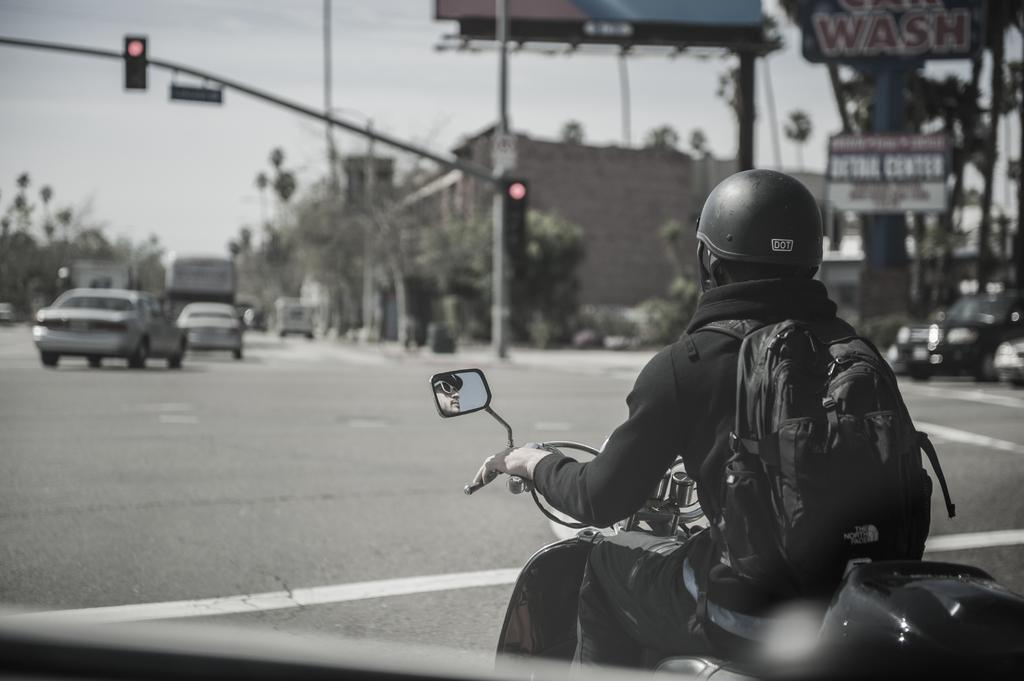What is the person in the image doing? The person is sitting and riding a bike. What is the person wearing while riding the bike? The person is wearing a bag and a helmet. What can be seen on the road in the image? There are vehicles on the road. What is visible in the distance in the image? There is a traffic signal with a pole, a building, boards, trees, and the sky. What type of bead is being used to decorate the cakes in the image? There are no cakes or beads present in the image; it features a person riding a bike and the surrounding environment. 